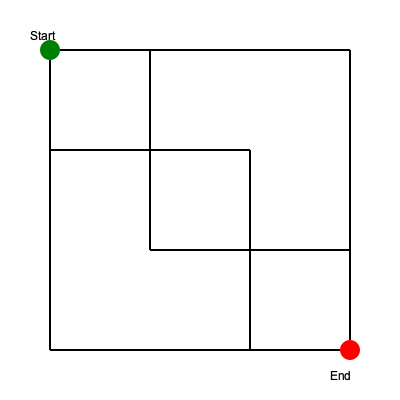As a speedrunner, identify the shortest path from the start (green) to the end (red) in this level layout. How many right-angle turns are required to complete the optimal route? To find the shortest path and count the right-angle turns:

1. Start at the green circle (top-left corner).
2. Move right until reaching the vertical line at x=150.
3. Turn 90 degrees and move down to y=150.
4. Turn 90 degrees and move right to x=250.
5. Turn 90 degrees and move down to y=250.
6. Turn 90 degrees and move right to x=350.
7. Move down to the red circle (bottom-right corner).

Counting the turns:
1. First turn at (150, 50)
2. Second turn at (150, 150)
3. Third turn at (250, 150)
4. Fourth turn at (250, 250)

The optimal route requires 4 right-angle turns.
Answer: 4 turns 